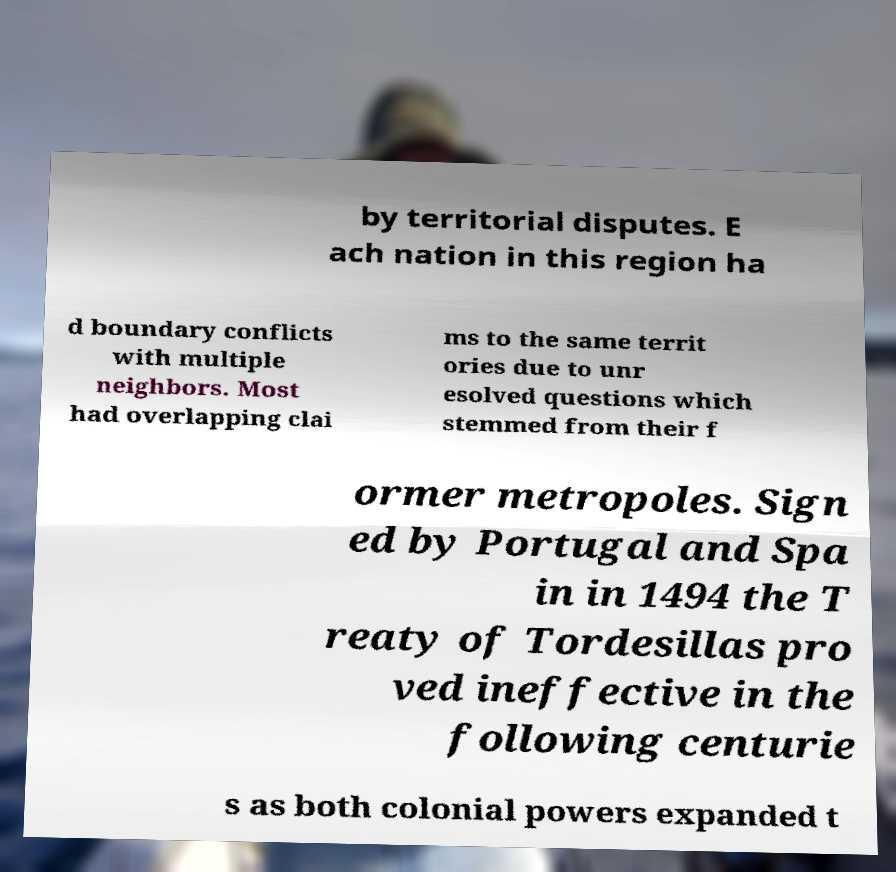There's text embedded in this image that I need extracted. Can you transcribe it verbatim? by territorial disputes. E ach nation in this region ha d boundary conflicts with multiple neighbors. Most had overlapping clai ms to the same territ ories due to unr esolved questions which stemmed from their f ormer metropoles. Sign ed by Portugal and Spa in in 1494 the T reaty of Tordesillas pro ved ineffective in the following centurie s as both colonial powers expanded t 